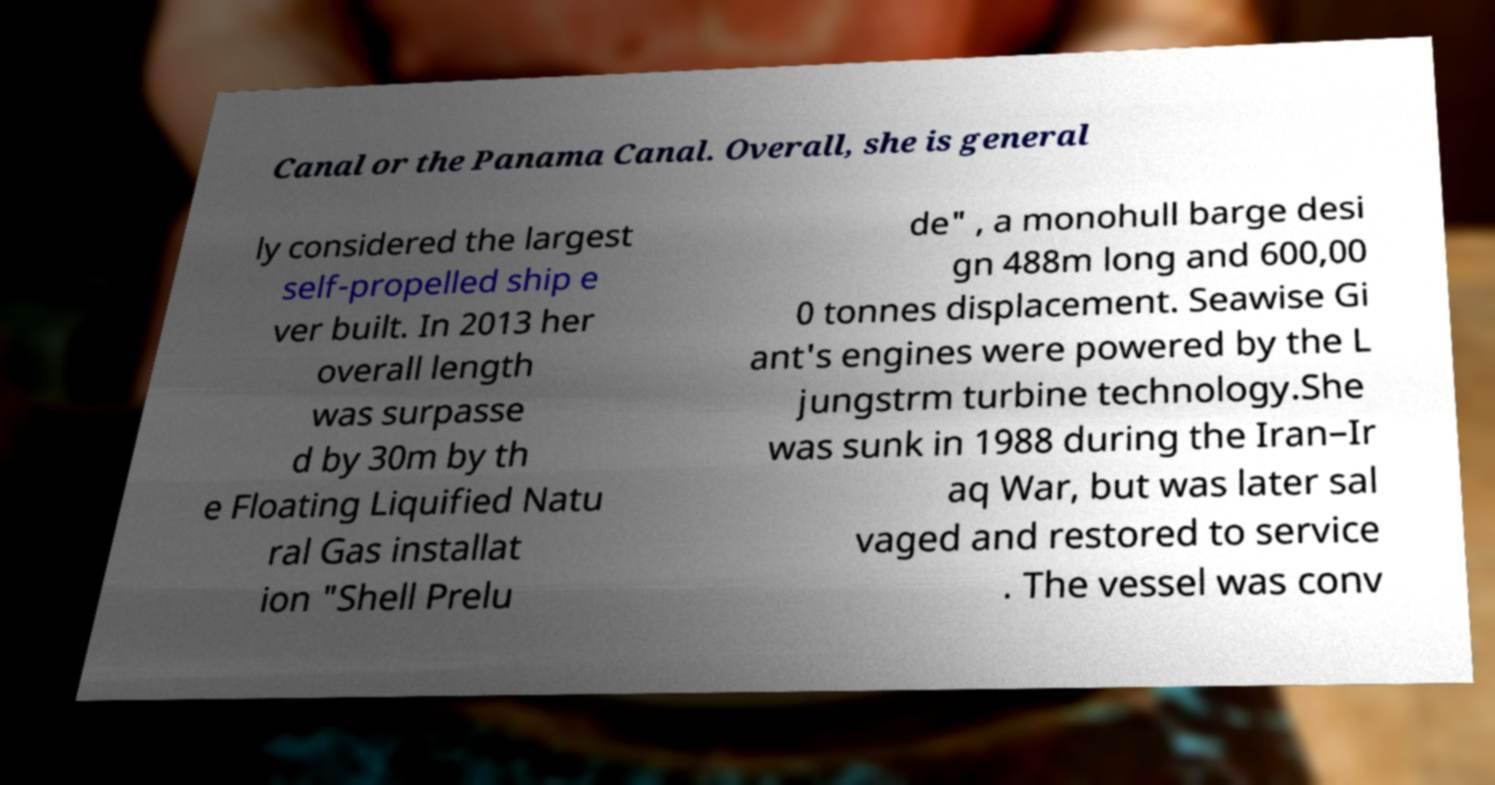I need the written content from this picture converted into text. Can you do that? Canal or the Panama Canal. Overall, she is general ly considered the largest self-propelled ship e ver built. In 2013 her overall length was surpasse d by 30m by th e Floating Liquified Natu ral Gas installat ion "Shell Prelu de" , a monohull barge desi gn 488m long and 600,00 0 tonnes displacement. Seawise Gi ant's engines were powered by the L jungstrm turbine technology.She was sunk in 1988 during the Iran–Ir aq War, but was later sal vaged and restored to service . The vessel was conv 